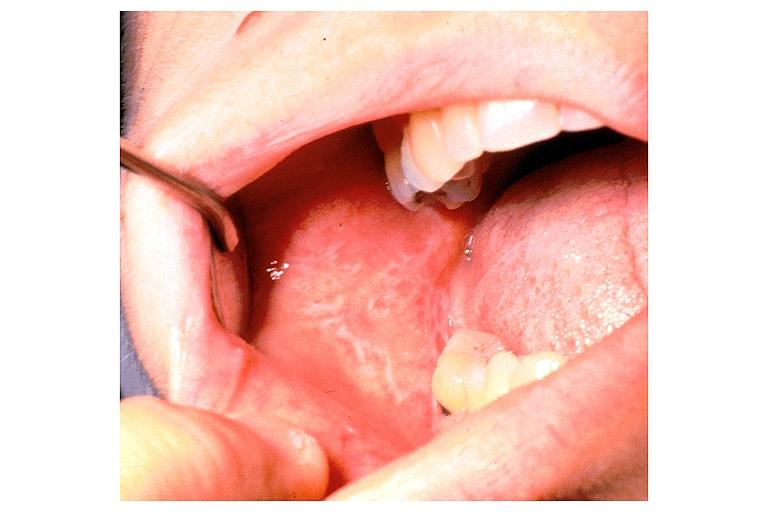does this image show lichen planus?
Answer the question using a single word or phrase. Yes 